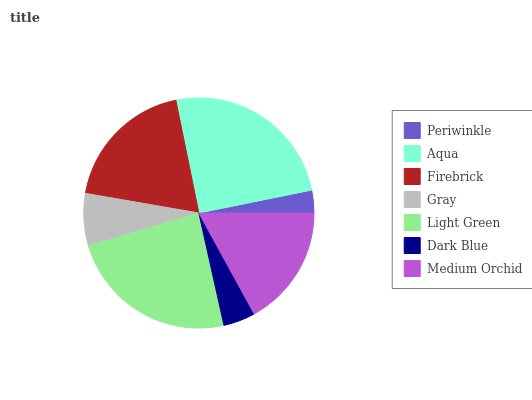Is Periwinkle the minimum?
Answer yes or no. Yes. Is Aqua the maximum?
Answer yes or no. Yes. Is Firebrick the minimum?
Answer yes or no. No. Is Firebrick the maximum?
Answer yes or no. No. Is Aqua greater than Firebrick?
Answer yes or no. Yes. Is Firebrick less than Aqua?
Answer yes or no. Yes. Is Firebrick greater than Aqua?
Answer yes or no. No. Is Aqua less than Firebrick?
Answer yes or no. No. Is Medium Orchid the high median?
Answer yes or no. Yes. Is Medium Orchid the low median?
Answer yes or no. Yes. Is Periwinkle the high median?
Answer yes or no. No. Is Light Green the low median?
Answer yes or no. No. 